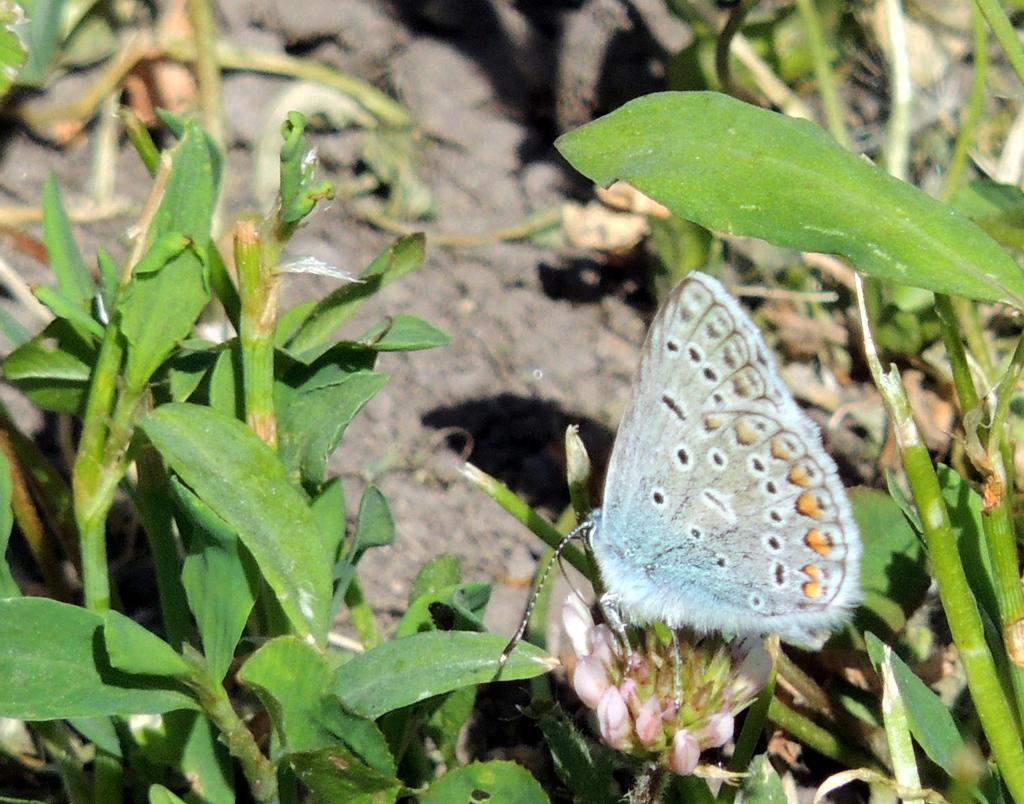What is the main subject of the image? There is a butterfly in the image. Where is the butterfly located in the image? The butterfly is sitting on buds. What else can be seen in the image besides the butterfly? There are buds on plants in the image. Can you describe the background of the image? The background of the image is slightly blurred. What type of music is playing in the background of the image? There is no music present in the image; it is a photograph of a butterfly sitting on buds. 